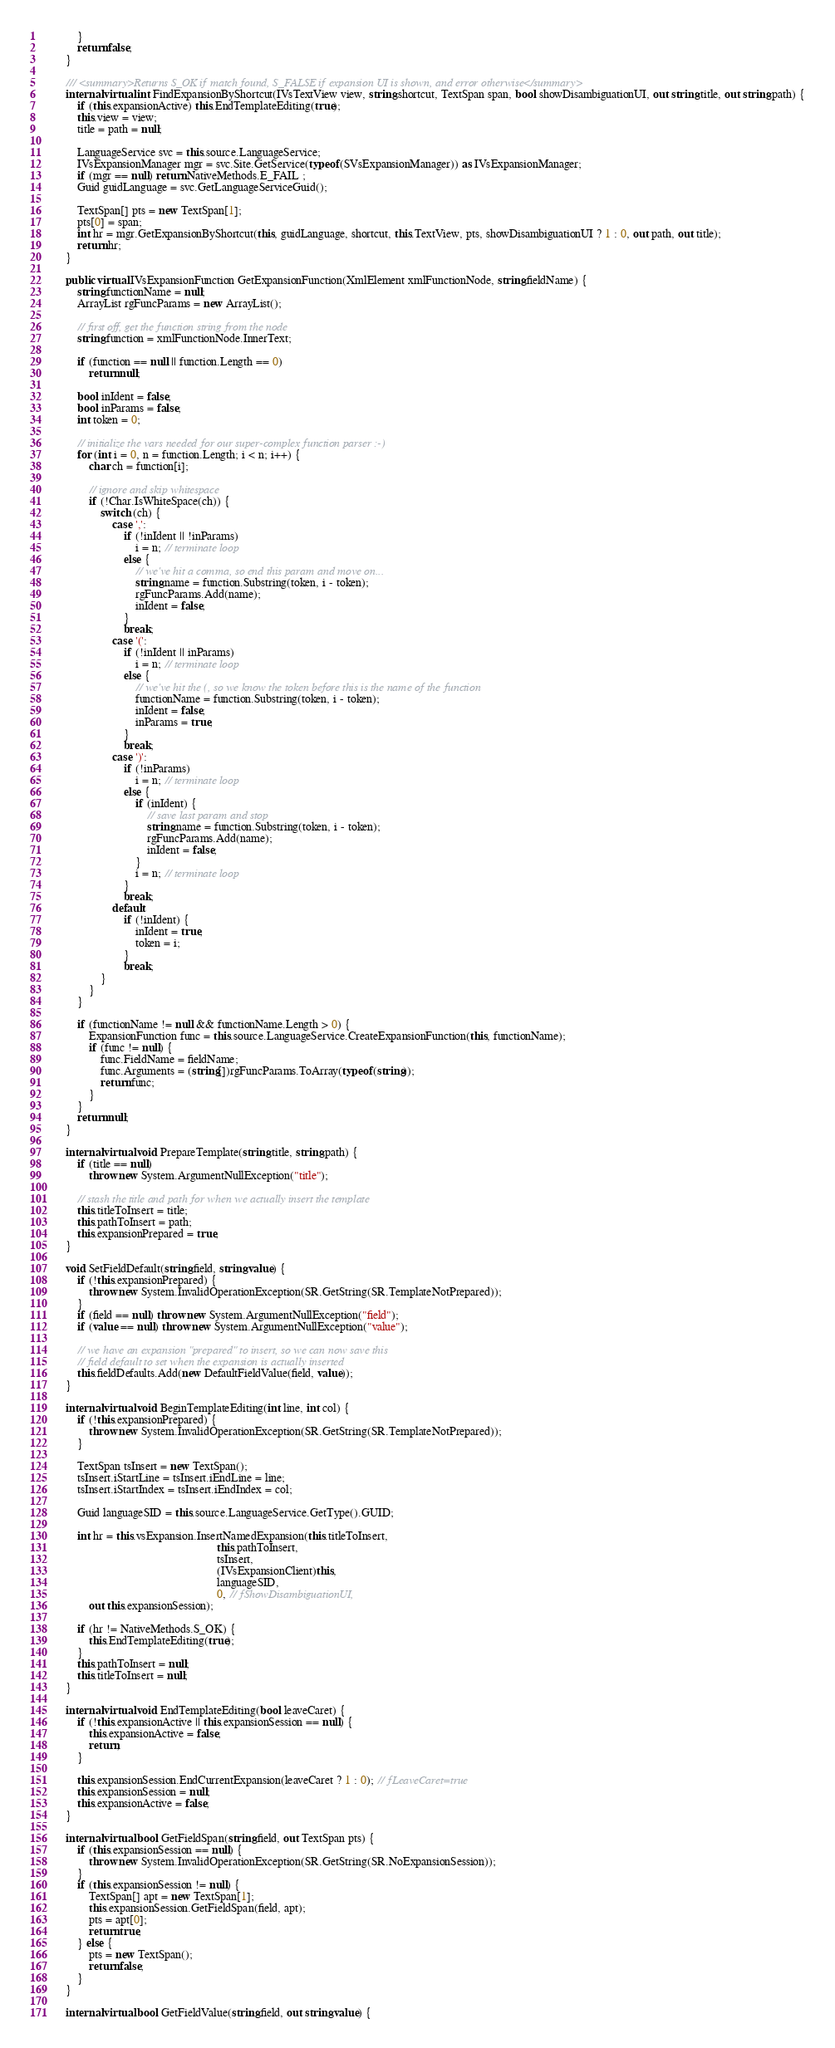Convert code to text. <code><loc_0><loc_0><loc_500><loc_500><_C#_>            }
            return false;
        }

        /// <summary>Returns S_OK if match found, S_FALSE if expansion UI is shown, and error otherwise</summary>
        internal virtual int FindExpansionByShortcut(IVsTextView view, string shortcut, TextSpan span, bool showDisambiguationUI, out string title, out string path) {
            if (this.expansionActive) this.EndTemplateEditing(true);
            this.view = view;
            title = path = null;

            LanguageService svc = this.source.LanguageService;
            IVsExpansionManager mgr = svc.Site.GetService(typeof(SVsExpansionManager)) as IVsExpansionManager;
            if (mgr == null) return NativeMethods.E_FAIL ;
            Guid guidLanguage = svc.GetLanguageServiceGuid();

            TextSpan[] pts = new TextSpan[1];
            pts[0] = span;
            int hr = mgr.GetExpansionByShortcut(this, guidLanguage, shortcut, this.TextView, pts, showDisambiguationUI ? 1 : 0, out path, out title);
            return hr;
        }

        public virtual IVsExpansionFunction GetExpansionFunction(XmlElement xmlFunctionNode, string fieldName) {
            string functionName = null;
            ArrayList rgFuncParams = new ArrayList();

            // first off, get the function string from the node
            string function = xmlFunctionNode.InnerText;

            if (function == null || function.Length == 0)
                return null;

            bool inIdent = false;
            bool inParams = false;
            int token = 0;

            // initialize the vars needed for our super-complex function parser :-)
            for (int i = 0, n = function.Length; i < n; i++) {
                char ch = function[i];

                // ignore and skip whitespace
                if (!Char.IsWhiteSpace(ch)) {
                    switch (ch) {
                        case ',':
                            if (!inIdent || !inParams)
                                i = n; // terminate loop
                            else {
                                // we've hit a comma, so end this param and move on...
                                string name = function.Substring(token, i - token);
                                rgFuncParams.Add(name);
                                inIdent = false;
                            }
                            break;
                        case '(':
                            if (!inIdent || inParams)
                                i = n; // terminate loop
                            else {
                                // we've hit the (, so we know the token before this is the name of the function
                                functionName = function.Substring(token, i - token);
                                inIdent = false;
                                inParams = true;
                            }
                            break;
                        case ')':
                            if (!inParams)
                                i = n; // terminate loop
                            else {
                                if (inIdent) {
                                    // save last param and stop
                                    string name = function.Substring(token, i - token);
                                    rgFuncParams.Add(name);
                                    inIdent = false;
                                }
                                i = n; // terminate loop
                            }
                            break;
                        default:
                            if (!inIdent) {
                                inIdent = true;
                                token = i;
                            }
                            break;
                    }
                }
            }

            if (functionName != null && functionName.Length > 0) {
                ExpansionFunction func = this.source.LanguageService.CreateExpansionFunction(this, functionName);
                if (func != null) {
                    func.FieldName = fieldName;
                    func.Arguments = (string[])rgFuncParams.ToArray(typeof(string));
                    return func;
                }
            }
            return null;
        }

        internal virtual void PrepareTemplate(string title, string path) {            
            if (title == null)
                throw new System.ArgumentNullException("title");

            // stash the title and path for when we actually insert the template
            this.titleToInsert = title;
            this.pathToInsert = path;
            this.expansionPrepared = true;
        }

        void SetFieldDefault(string field, string value) {
            if (!this.expansionPrepared) {
                throw new System.InvalidOperationException(SR.GetString(SR.TemplateNotPrepared));
            }
            if (field == null) throw new System.ArgumentNullException("field");
            if (value == null) throw new System.ArgumentNullException("value");

            // we have an expansion "prepared" to insert, so we can now save this
            // field default to set when the expansion is actually inserted
            this.fieldDefaults.Add(new DefaultFieldValue(field, value));
        }

        internal virtual void BeginTemplateEditing(int line, int col) {
            if (!this.expansionPrepared) {
                throw new System.InvalidOperationException(SR.GetString(SR.TemplateNotPrepared));
            }

            TextSpan tsInsert = new TextSpan();
            tsInsert.iStartLine = tsInsert.iEndLine = line;
            tsInsert.iStartIndex = tsInsert.iEndIndex = col;

            Guid languageSID = this.source.LanguageService.GetType().GUID;

            int hr = this.vsExpansion.InsertNamedExpansion(this.titleToInsert,
                                                            this.pathToInsert,
                                                            tsInsert,
                                                            (IVsExpansionClient)this,
                                                            languageSID,
                                                            0, // fShowDisambiguationUI,
                out this.expansionSession);

            if (hr != NativeMethods.S_OK) {
                this.EndTemplateEditing(true);
            }
            this.pathToInsert = null;
            this.titleToInsert = null;
        }

        internal virtual void EndTemplateEditing(bool leaveCaret) {
            if (!this.expansionActive || this.expansionSession == null) {
                this.expansionActive = false;
                return;
            }

            this.expansionSession.EndCurrentExpansion(leaveCaret ? 1 : 0); // fLeaveCaret=true
            this.expansionSession = null;
            this.expansionActive = false;
        }

        internal virtual bool GetFieldSpan(string field, out TextSpan pts) {
            if (this.expansionSession == null) {
                throw new System.InvalidOperationException(SR.GetString(SR.NoExpansionSession));
            }
            if (this.expansionSession != null) {
                TextSpan[] apt = new TextSpan[1];
                this.expansionSession.GetFieldSpan(field, apt);
                pts = apt[0];
                return true;
            } else {
                pts = new TextSpan();
                return false;
            }
        }

        internal virtual bool GetFieldValue(string field, out string value) {</code> 